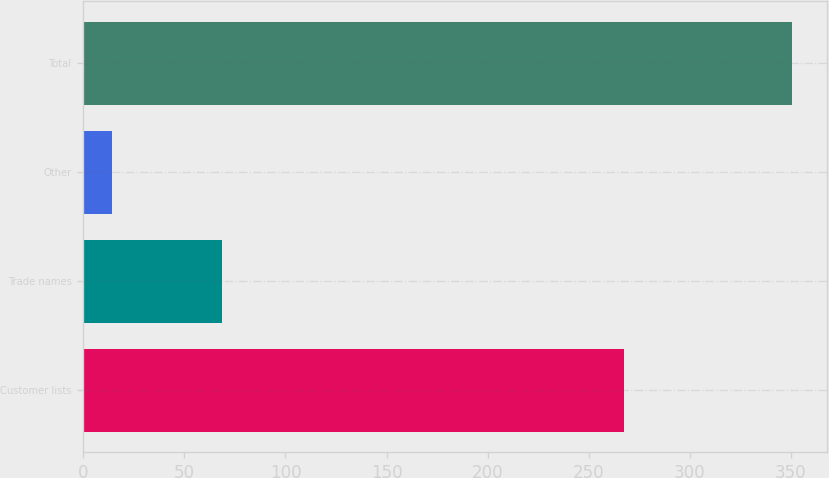<chart> <loc_0><loc_0><loc_500><loc_500><bar_chart><fcel>Customer lists<fcel>Trade names<fcel>Other<fcel>Total<nl><fcel>267.3<fcel>68.8<fcel>14.4<fcel>350.5<nl></chart> 